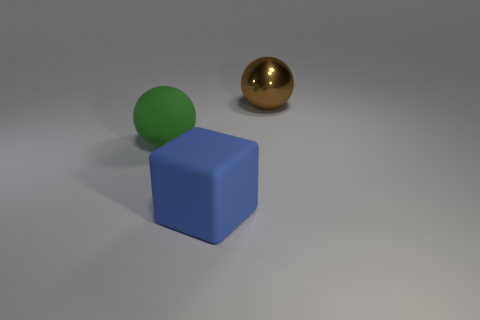What materials do the objects in the image appear to be made of? The objects in the image appear to be made of different materials. The cube has a matte surface suggesting it could be made of a material like rubber or plastic, while the large shiny sphere has a reflective surface, which implies it might be metallic. The smaller sphere's flat color and lack of reflection or transparency indicate it could also be made of a matte material like the cube, possibly rubber or plastic. 